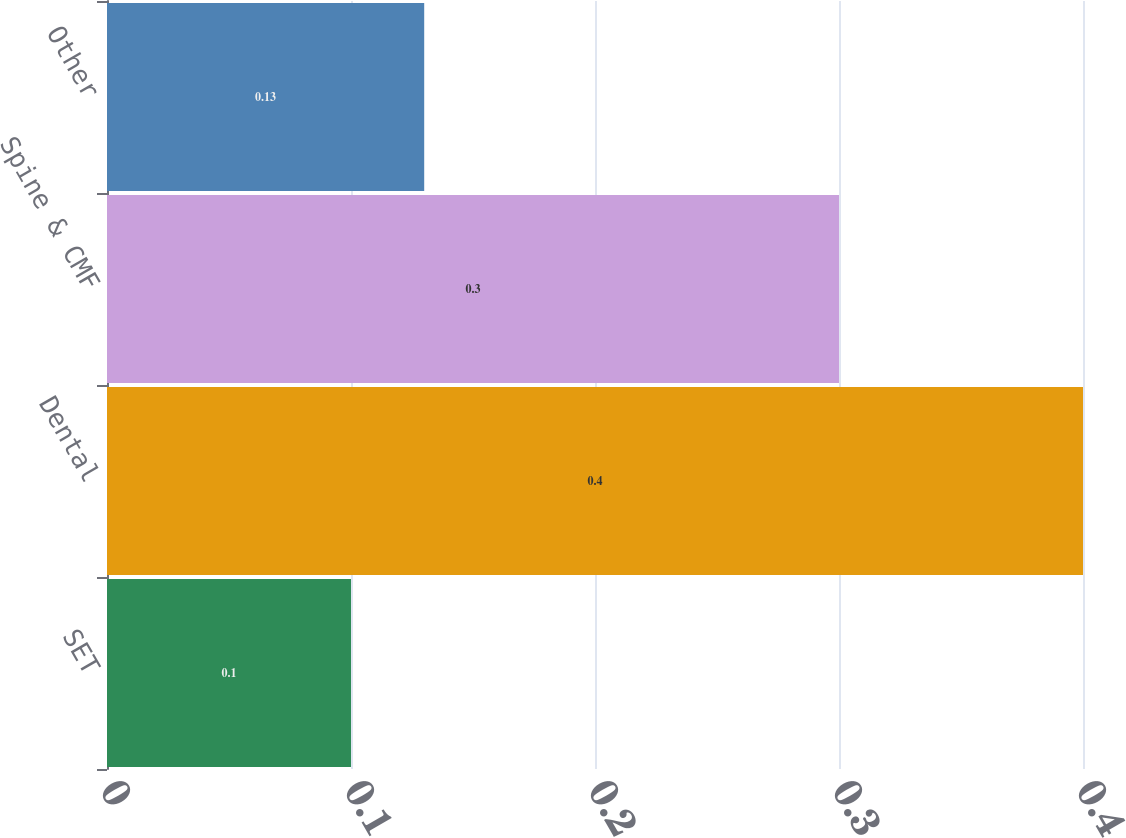<chart> <loc_0><loc_0><loc_500><loc_500><bar_chart><fcel>SET<fcel>Dental<fcel>Spine & CMF<fcel>Other<nl><fcel>0.1<fcel>0.4<fcel>0.3<fcel>0.13<nl></chart> 